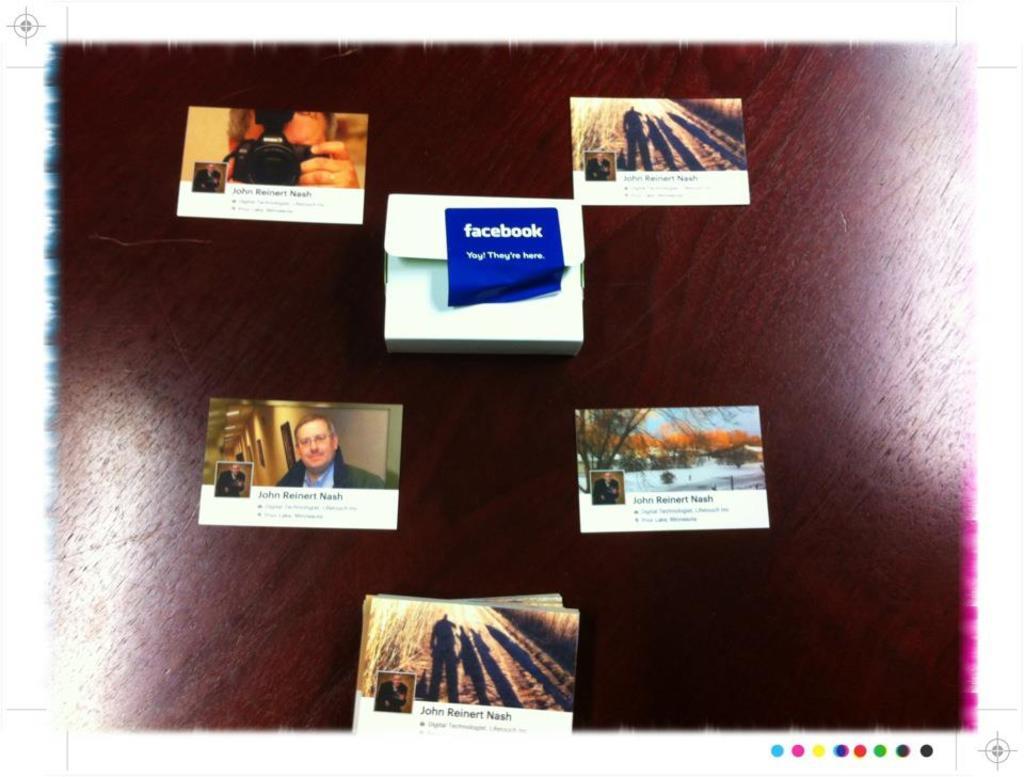What social network is shown on the center image?
Provide a short and direct response. Facebook. 